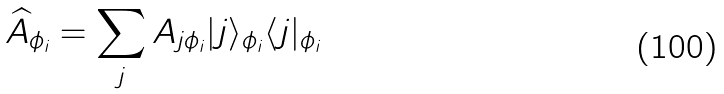Convert formula to latex. <formula><loc_0><loc_0><loc_500><loc_500>\widehat { A } _ { \phi _ { i } } = \sum _ { j } A _ { j \phi _ { i } } | j \rangle _ { \phi _ { i } } \langle j | _ { \phi _ { i } }</formula> 